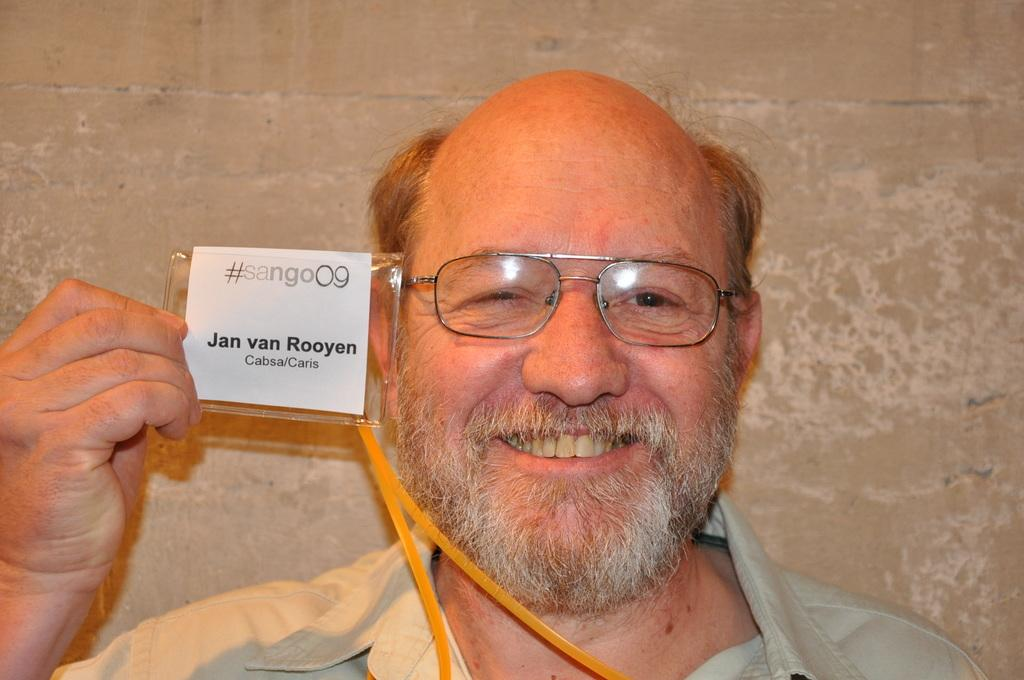What is the main subject of the image? There is a person in the image. What is the person holding in the image? The person is holding a card. Can you describe the card? There is text on the card. What is visible in the background of the image? There is a wall in the background of the image. Can you hear any thunder in the image? There is no sound present in the image, so it is not possible to determine if there is thunder or not. 